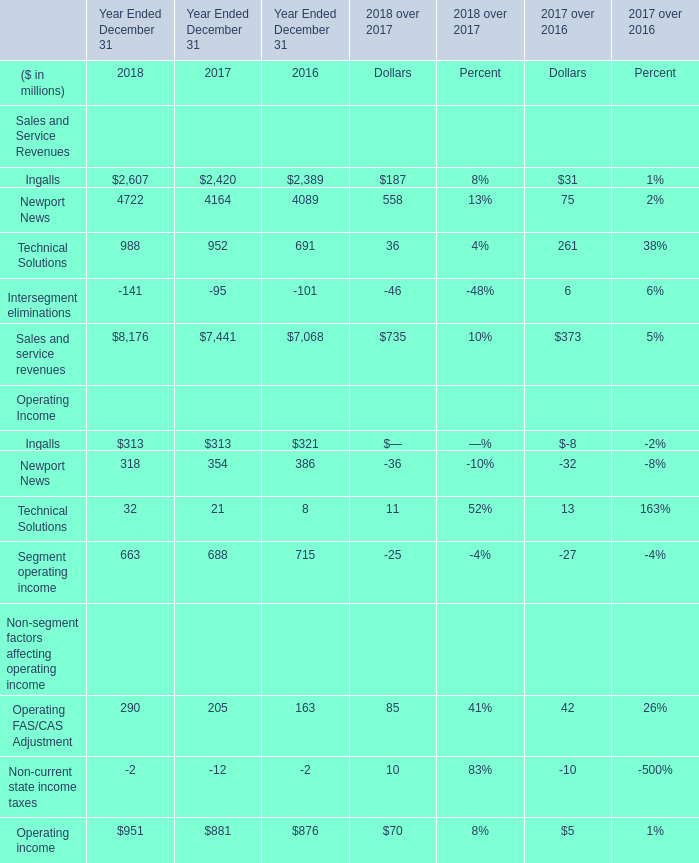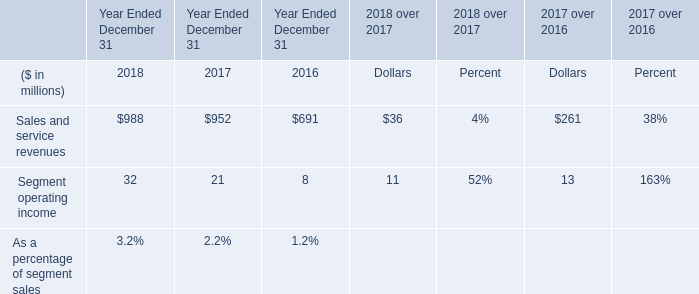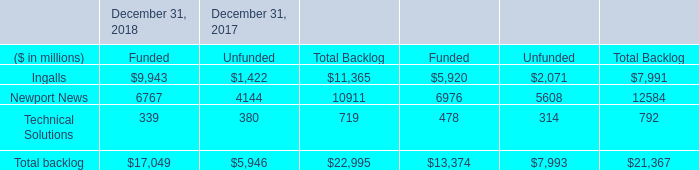what's the total amount of Newport News of December 31, 2017 Unfunded, Ingalls of Year Ended December 31 2016, and Newport News of December 31, 2017 Total Backlog ? 
Computations: ((4144.0 + 2389.0) + 10911.0)
Answer: 17444.0. 